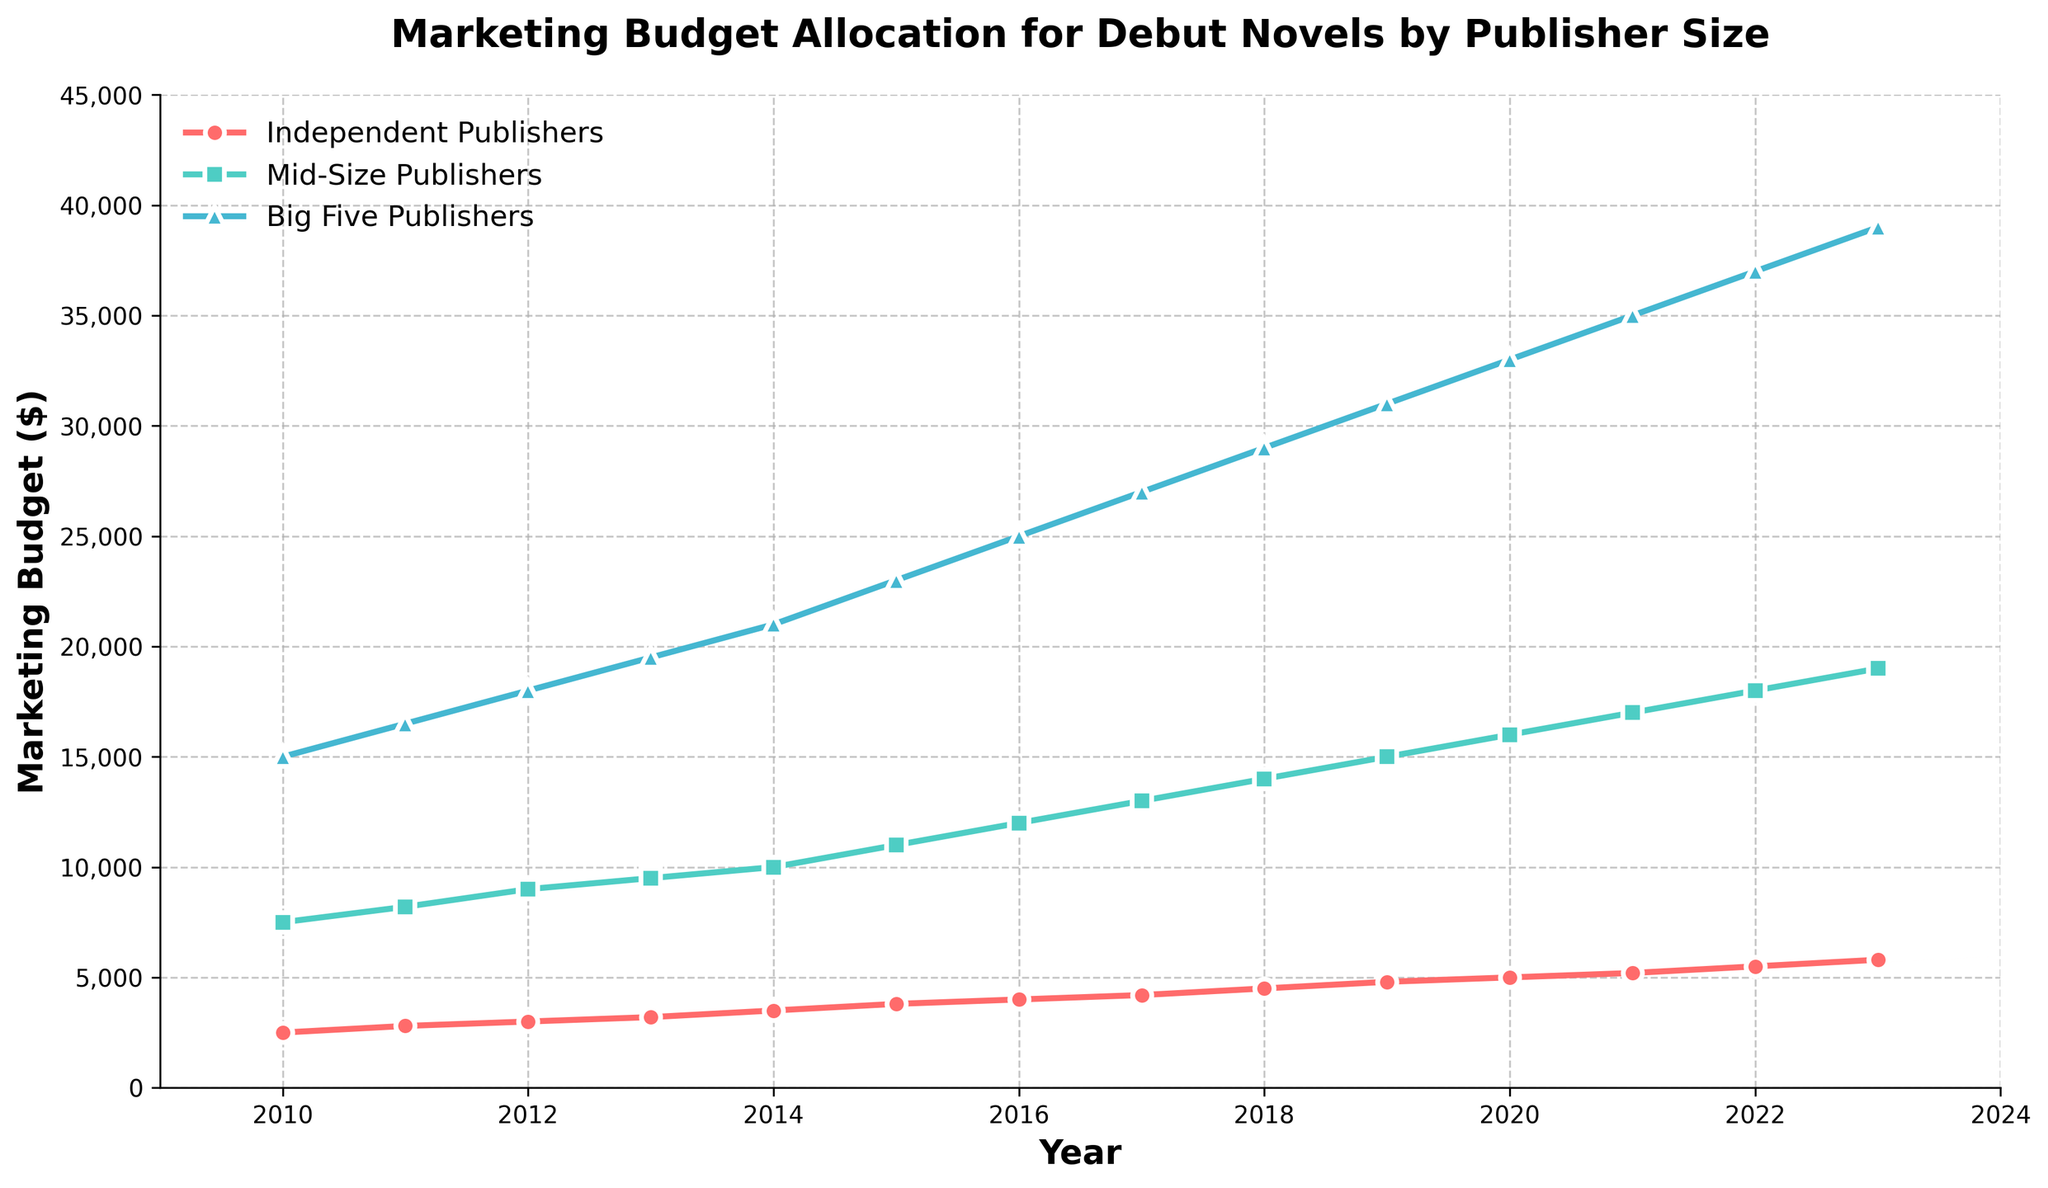What was the marketing budget allocated by Mid-Size Publishers in 2015? Look at the point for Mid-Size Publishers on the year 2015. The budget allocated is 11,000 dollars.
Answer: 11,000 dollars Between which years did Independent Publishers' marketing budget increase by the largest absolute amount? Calculate the difference in budget for each consecutive year for Independent Publishers, and check which one has the highest difference. From 2019 to 2020, it increased by 500 dollars (from 4,800 to 5,000 dollars).
Answer: 2019 to 2020 Which publisher size had the highest marketing budget in 2023? Look at the points for each publisher size in the year 2023. The Big Five Publishers have the highest budget at 39,000 dollars.
Answer: Big Five Publishers By how much did the marketing budget for Big Five Publishers increase from 2010 to 2023? Look at the first point (2010) and the last point (2023) for Big Five Publishers, and find the difference: 39,000 dollars - 15,000 dollars = 24,000 dollars.
Answer: 24,000 dollars What is the trend in the marketing budget of Mid-Size Publishers from 2010 to 2023? Observe the line representing Mid-Size Publishers from 2010 to 2023. The budget shows a steady increase each year.
Answer: A steady increase How much higher is the 2023 marketing budget of Independent Publishers compared to that of 2010? Look at the budget in 2023 and 2010 for Independent Publishers and find the difference: 5,800 dollars - 2,500 dollars = 3,300 dollars.
Answer: 3,300 dollars In which year did the Big Five Publishers’ budget first exceed 30,000 dollars? Look at the line of Big Five Publishers and find the first year where the budget exceeds 30,000 dollars. That year is 2019.
Answer: 2019 Compare the marketing budgets of Independent Publishers and Big Five Publishers in 2018. What is the difference? Look at the values for both Independent Publishers and Big Five Publishers in 2018. The difference is 29,000 dollars - 4,500 dollars = 24,500 dollars.
Answer: 24,500 dollars What is the average marketing budget of Independent Publishers from 2010 to 2023? Sum all the yearly budgets of Independent Publishers from 2010 to 2023 and divide by the number of years. (2500 + 2800 + 3000 + 3200 + 3500 + 3800 + 4000 + 4200 + 4500 + 4800 + 5000 + 5200 + 5500 + 5800) / 14 = 4,050 dollars.
Answer: 4,050 dollars By what percentage did the marketing budget for Mid-Size Publishers increase from 2010 to 2023? Calculate the percentage increase using the formula [(final value - initial value) / initial value] * 100. For Mid-Size Publishers, [(19,000 - 7,500) / 7,500] * 100 ≈ 153.33%.
Answer: Approximately 153.33% 